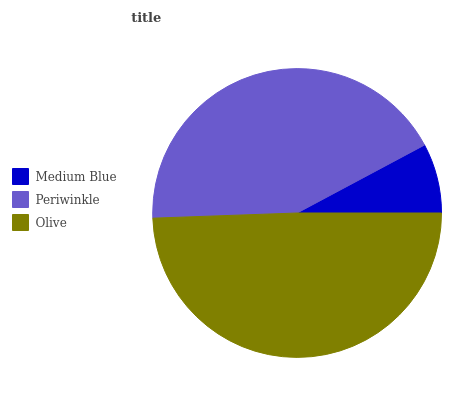Is Medium Blue the minimum?
Answer yes or no. Yes. Is Olive the maximum?
Answer yes or no. Yes. Is Periwinkle the minimum?
Answer yes or no. No. Is Periwinkle the maximum?
Answer yes or no. No. Is Periwinkle greater than Medium Blue?
Answer yes or no. Yes. Is Medium Blue less than Periwinkle?
Answer yes or no. Yes. Is Medium Blue greater than Periwinkle?
Answer yes or no. No. Is Periwinkle less than Medium Blue?
Answer yes or no. No. Is Periwinkle the high median?
Answer yes or no. Yes. Is Periwinkle the low median?
Answer yes or no. Yes. Is Medium Blue the high median?
Answer yes or no. No. Is Medium Blue the low median?
Answer yes or no. No. 